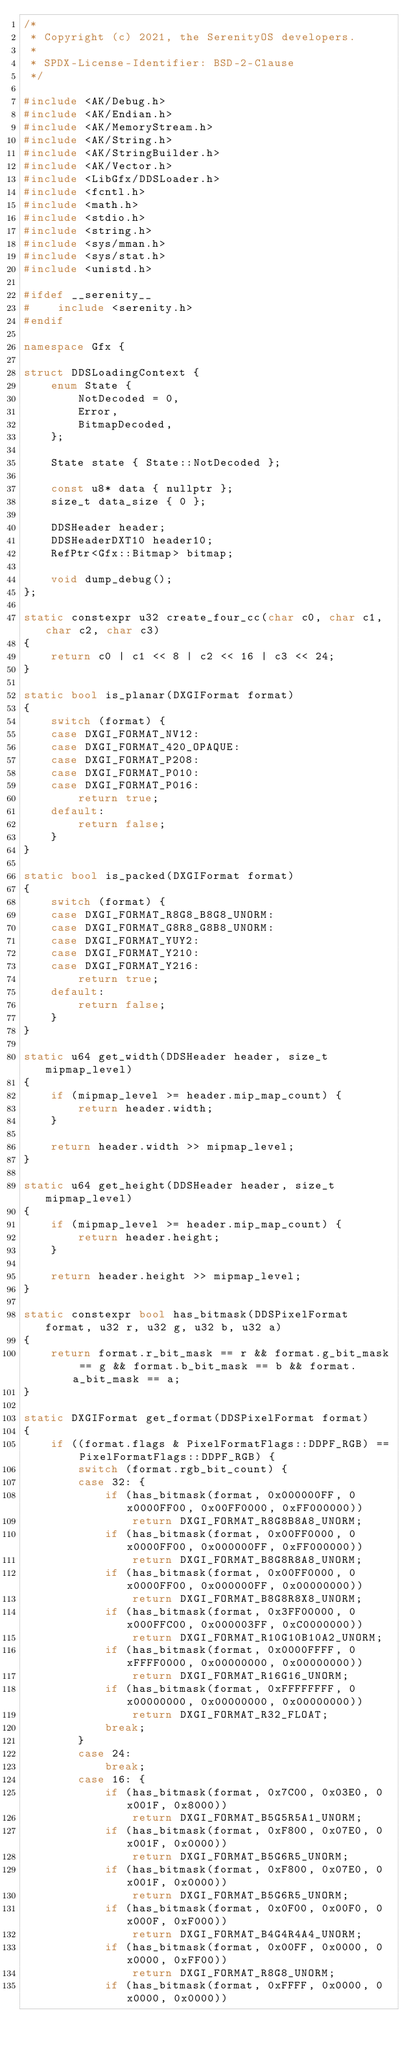<code> <loc_0><loc_0><loc_500><loc_500><_C++_>/*
 * Copyright (c) 2021, the SerenityOS developers.
 *
 * SPDX-License-Identifier: BSD-2-Clause
 */

#include <AK/Debug.h>
#include <AK/Endian.h>
#include <AK/MemoryStream.h>
#include <AK/String.h>
#include <AK/StringBuilder.h>
#include <AK/Vector.h>
#include <LibGfx/DDSLoader.h>
#include <fcntl.h>
#include <math.h>
#include <stdio.h>
#include <string.h>
#include <sys/mman.h>
#include <sys/stat.h>
#include <unistd.h>

#ifdef __serenity__
#    include <serenity.h>
#endif

namespace Gfx {

struct DDSLoadingContext {
    enum State {
        NotDecoded = 0,
        Error,
        BitmapDecoded,
    };

    State state { State::NotDecoded };

    const u8* data { nullptr };
    size_t data_size { 0 };

    DDSHeader header;
    DDSHeaderDXT10 header10;
    RefPtr<Gfx::Bitmap> bitmap;

    void dump_debug();
};

static constexpr u32 create_four_cc(char c0, char c1, char c2, char c3)
{
    return c0 | c1 << 8 | c2 << 16 | c3 << 24;
}

static bool is_planar(DXGIFormat format)
{
    switch (format) {
    case DXGI_FORMAT_NV12:
    case DXGI_FORMAT_420_OPAQUE:
    case DXGI_FORMAT_P208:
    case DXGI_FORMAT_P010:
    case DXGI_FORMAT_P016:
        return true;
    default:
        return false;
    }
}

static bool is_packed(DXGIFormat format)
{
    switch (format) {
    case DXGI_FORMAT_R8G8_B8G8_UNORM:
    case DXGI_FORMAT_G8R8_G8B8_UNORM:
    case DXGI_FORMAT_YUY2:
    case DXGI_FORMAT_Y210:
    case DXGI_FORMAT_Y216:
        return true;
    default:
        return false;
    }
}

static u64 get_width(DDSHeader header, size_t mipmap_level)
{
    if (mipmap_level >= header.mip_map_count) {
        return header.width;
    }

    return header.width >> mipmap_level;
}

static u64 get_height(DDSHeader header, size_t mipmap_level)
{
    if (mipmap_level >= header.mip_map_count) {
        return header.height;
    }

    return header.height >> mipmap_level;
}

static constexpr bool has_bitmask(DDSPixelFormat format, u32 r, u32 g, u32 b, u32 a)
{
    return format.r_bit_mask == r && format.g_bit_mask == g && format.b_bit_mask == b && format.a_bit_mask == a;
}

static DXGIFormat get_format(DDSPixelFormat format)
{
    if ((format.flags & PixelFormatFlags::DDPF_RGB) == PixelFormatFlags::DDPF_RGB) {
        switch (format.rgb_bit_count) {
        case 32: {
            if (has_bitmask(format, 0x000000FF, 0x0000FF00, 0x00FF0000, 0xFF000000))
                return DXGI_FORMAT_R8G8B8A8_UNORM;
            if (has_bitmask(format, 0x00FF0000, 0x0000FF00, 0x000000FF, 0xFF000000))
                return DXGI_FORMAT_B8G8R8A8_UNORM;
            if (has_bitmask(format, 0x00FF0000, 0x0000FF00, 0x000000FF, 0x00000000))
                return DXGI_FORMAT_B8G8R8X8_UNORM;
            if (has_bitmask(format, 0x3FF00000, 0x000FFC00, 0x000003FF, 0xC0000000))
                return DXGI_FORMAT_R10G10B10A2_UNORM;
            if (has_bitmask(format, 0x0000FFFF, 0xFFFF0000, 0x00000000, 0x00000000))
                return DXGI_FORMAT_R16G16_UNORM;
            if (has_bitmask(format, 0xFFFFFFFF, 0x00000000, 0x00000000, 0x00000000))
                return DXGI_FORMAT_R32_FLOAT;
            break;
        }
        case 24:
            break;
        case 16: {
            if (has_bitmask(format, 0x7C00, 0x03E0, 0x001F, 0x8000))
                return DXGI_FORMAT_B5G5R5A1_UNORM;
            if (has_bitmask(format, 0xF800, 0x07E0, 0x001F, 0x0000))
                return DXGI_FORMAT_B5G6R5_UNORM;
            if (has_bitmask(format, 0xF800, 0x07E0, 0x001F, 0x0000))
                return DXGI_FORMAT_B5G6R5_UNORM;
            if (has_bitmask(format, 0x0F00, 0x00F0, 0x000F, 0xF000))
                return DXGI_FORMAT_B4G4R4A4_UNORM;
            if (has_bitmask(format, 0x00FF, 0x0000, 0x0000, 0xFF00))
                return DXGI_FORMAT_R8G8_UNORM;
            if (has_bitmask(format, 0xFFFF, 0x0000, 0x0000, 0x0000))</code> 